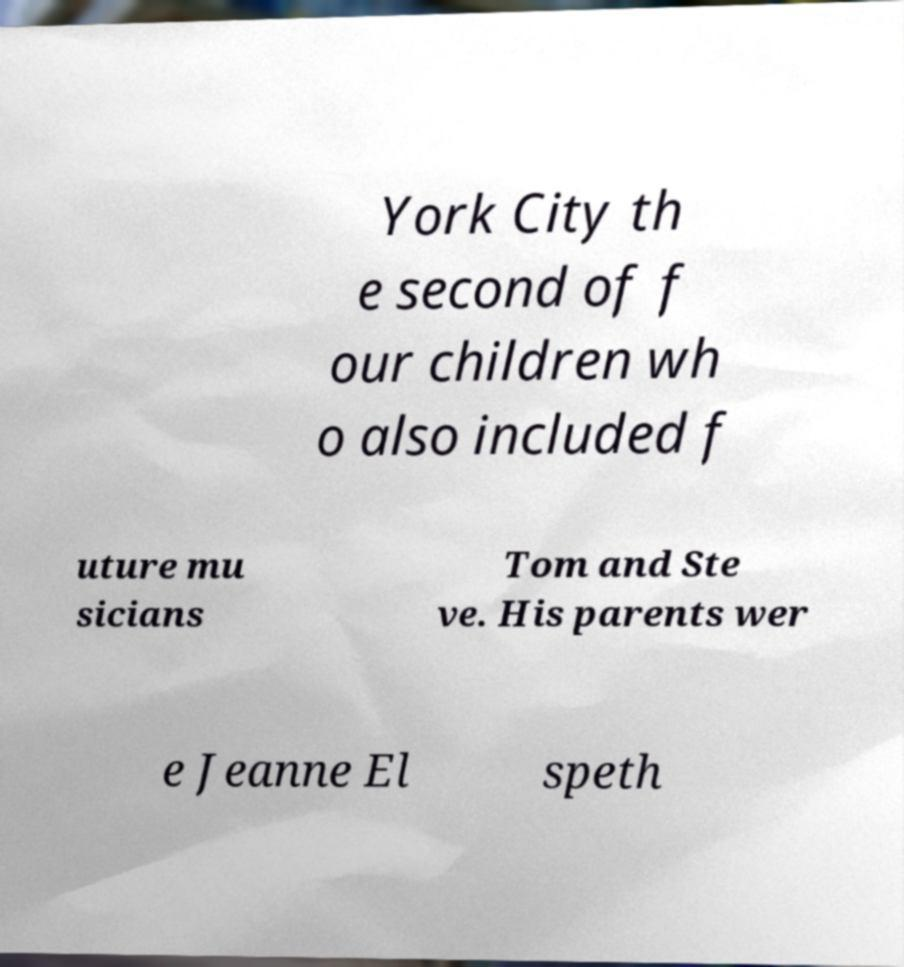Please identify and transcribe the text found in this image. York City th e second of f our children wh o also included f uture mu sicians Tom and Ste ve. His parents wer e Jeanne El speth 